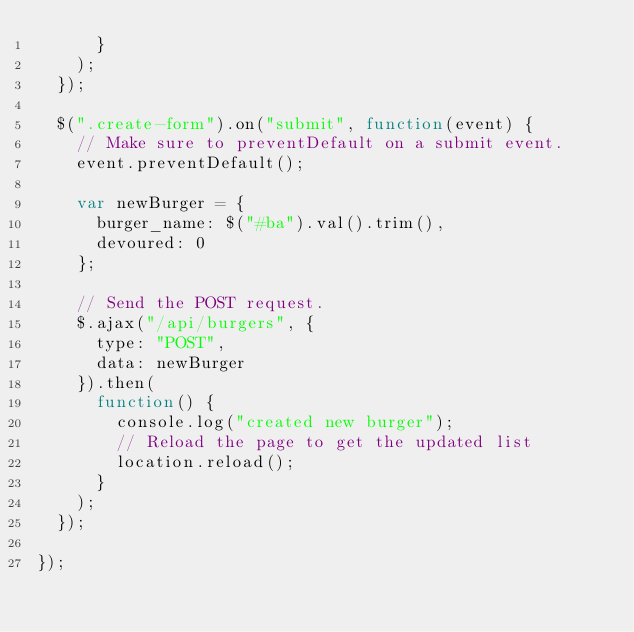<code> <loc_0><loc_0><loc_500><loc_500><_JavaScript_>      }
    );
  });

  $(".create-form").on("submit", function(event) {
    // Make sure to preventDefault on a submit event.
    event.preventDefault();

    var newBurger = {
      burger_name: $("#ba").val().trim(),
      devoured: 0
    };

    // Send the POST request.
    $.ajax("/api/burgers", {
      type: "POST",
      data: newBurger
    }).then(
      function() {
        console.log("created new burger");
        // Reload the page to get the updated list
        location.reload();
      }
    );
  });

});
</code> 